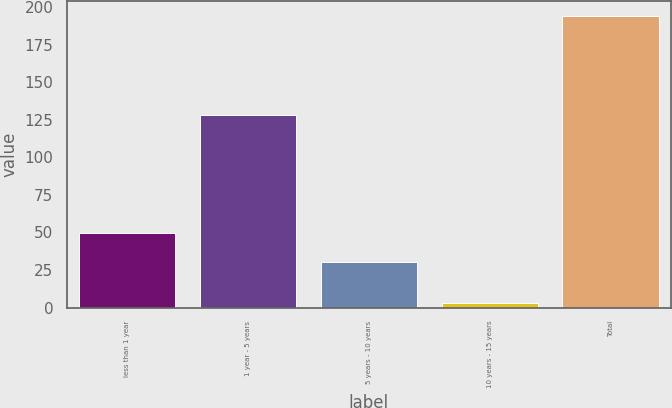Convert chart. <chart><loc_0><loc_0><loc_500><loc_500><bar_chart><fcel>less than 1 year<fcel>1 year - 5 years<fcel>5 years - 10 years<fcel>10 years - 15 years<fcel>Total<nl><fcel>49.3<fcel>128.3<fcel>30.2<fcel>3.3<fcel>194.3<nl></chart> 